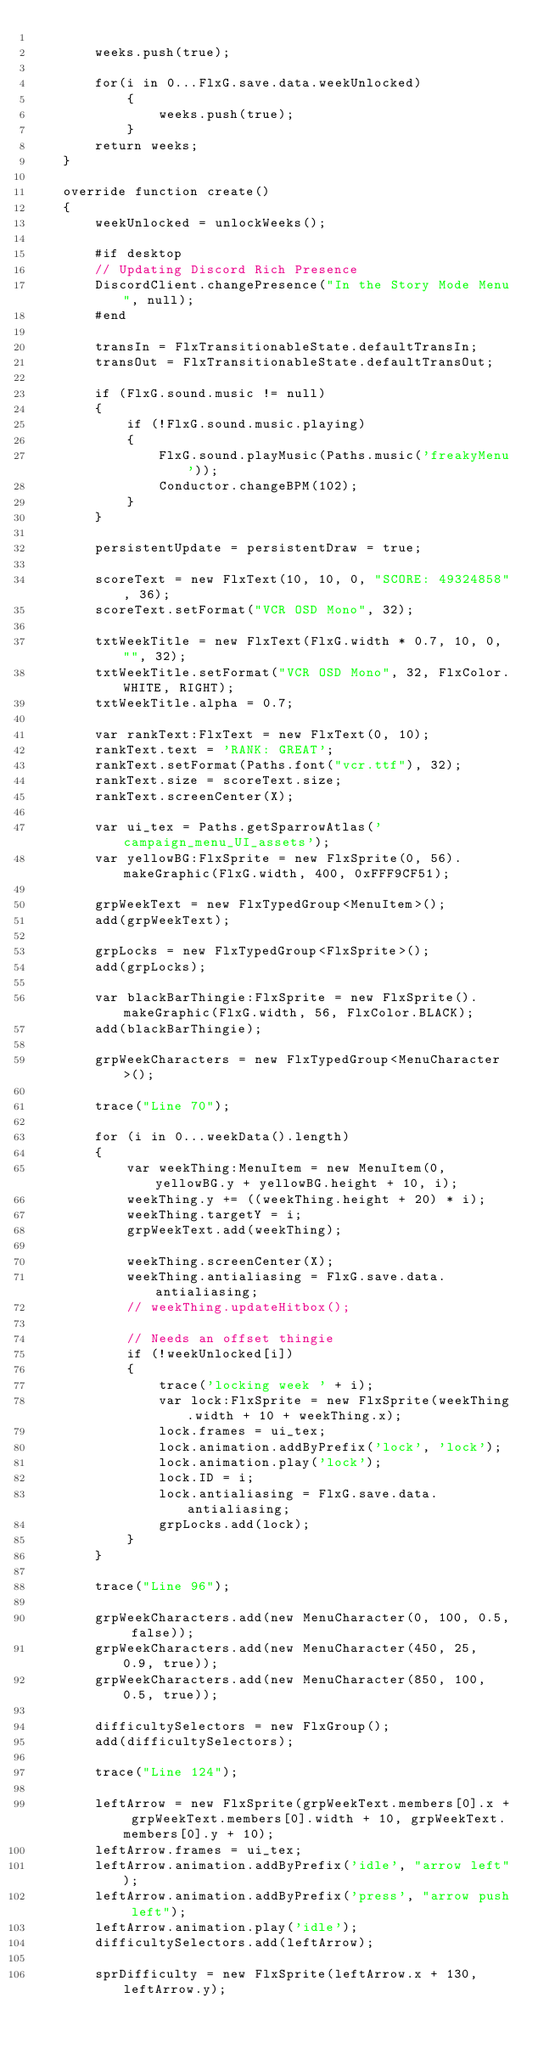Convert code to text. <code><loc_0><loc_0><loc_500><loc_500><_Haxe_>		
		weeks.push(true);

		for(i in 0...FlxG.save.data.weekUnlocked)
			{
				weeks.push(true);
			}
		return weeks;
	}

	override function create()
	{
		weekUnlocked = unlockWeeks();

		#if desktop
		// Updating Discord Rich Presence
		DiscordClient.changePresence("In the Story Mode Menu", null);
		#end

		transIn = FlxTransitionableState.defaultTransIn;
		transOut = FlxTransitionableState.defaultTransOut;

		if (FlxG.sound.music != null)
		{
			if (!FlxG.sound.music.playing)
			{
				FlxG.sound.playMusic(Paths.music('freakyMenu'));
				Conductor.changeBPM(102);
			}
		}

		persistentUpdate = persistentDraw = true;

		scoreText = new FlxText(10, 10, 0, "SCORE: 49324858", 36);
		scoreText.setFormat("VCR OSD Mono", 32);

		txtWeekTitle = new FlxText(FlxG.width * 0.7, 10, 0, "", 32);
		txtWeekTitle.setFormat("VCR OSD Mono", 32, FlxColor.WHITE, RIGHT);
		txtWeekTitle.alpha = 0.7;

		var rankText:FlxText = new FlxText(0, 10);
		rankText.text = 'RANK: GREAT';
		rankText.setFormat(Paths.font("vcr.ttf"), 32);
		rankText.size = scoreText.size;
		rankText.screenCenter(X);

		var ui_tex = Paths.getSparrowAtlas('campaign_menu_UI_assets');
		var yellowBG:FlxSprite = new FlxSprite(0, 56).makeGraphic(FlxG.width, 400, 0xFFF9CF51);

		grpWeekText = new FlxTypedGroup<MenuItem>();
		add(grpWeekText);

		grpLocks = new FlxTypedGroup<FlxSprite>();
		add(grpLocks);

		var blackBarThingie:FlxSprite = new FlxSprite().makeGraphic(FlxG.width, 56, FlxColor.BLACK);
		add(blackBarThingie);

		grpWeekCharacters = new FlxTypedGroup<MenuCharacter>();

		trace("Line 70");

		for (i in 0...weekData().length)
		{
			var weekThing:MenuItem = new MenuItem(0, yellowBG.y + yellowBG.height + 10, i);
			weekThing.y += ((weekThing.height + 20) * i);
			weekThing.targetY = i;
			grpWeekText.add(weekThing);

			weekThing.screenCenter(X);
			weekThing.antialiasing = FlxG.save.data.antialiasing;
			// weekThing.updateHitbox();

			// Needs an offset thingie
			if (!weekUnlocked[i])
			{
				trace('locking week ' + i);
				var lock:FlxSprite = new FlxSprite(weekThing.width + 10 + weekThing.x);
				lock.frames = ui_tex;
				lock.animation.addByPrefix('lock', 'lock');
				lock.animation.play('lock');
				lock.ID = i;
				lock.antialiasing = FlxG.save.data.antialiasing;
				grpLocks.add(lock);
			}
		}

		trace("Line 96");

		grpWeekCharacters.add(new MenuCharacter(0, 100, 0.5, false));
		grpWeekCharacters.add(new MenuCharacter(450, 25, 0.9, true));
		grpWeekCharacters.add(new MenuCharacter(850, 100, 0.5, true));

		difficultySelectors = new FlxGroup();
		add(difficultySelectors);

		trace("Line 124");

		leftArrow = new FlxSprite(grpWeekText.members[0].x + grpWeekText.members[0].width + 10, grpWeekText.members[0].y + 10);
		leftArrow.frames = ui_tex;
		leftArrow.animation.addByPrefix('idle', "arrow left");
		leftArrow.animation.addByPrefix('press', "arrow push left");
		leftArrow.animation.play('idle');
		difficultySelectors.add(leftArrow);

		sprDifficulty = new FlxSprite(leftArrow.x + 130, leftArrow.y);</code> 